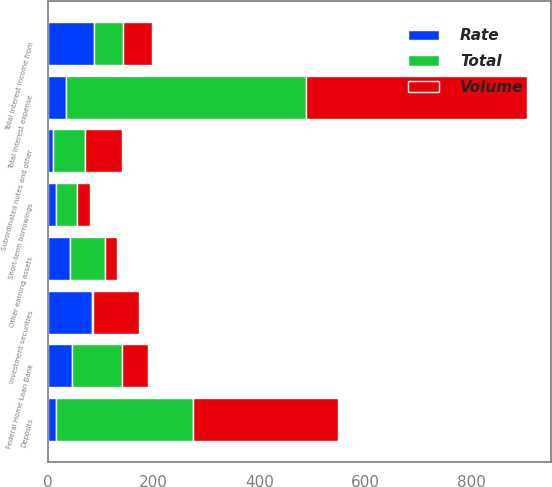Convert chart to OTSL. <chart><loc_0><loc_0><loc_500><loc_500><stacked_bar_chart><ecel><fcel>Investment securities<fcel>Other earning assets<fcel>Total interest income from<fcel>Deposits<fcel>Short-term borrowings<fcel>Federal Home Loan Bank<fcel>Subordinated notes and other<fcel>Total interest expense<nl><fcel>Rate<fcel>84.4<fcel>42.1<fcel>87.9<fcel>16.5<fcel>16.6<fcel>45.3<fcel>9.8<fcel>35.6<nl><fcel>Volume<fcel>86.3<fcel>23.4<fcel>54.95<fcel>274.1<fcel>23.3<fcel>49.6<fcel>70.1<fcel>417.1<nl><fcel>Total<fcel>1.9<fcel>65.5<fcel>54.95<fcel>257.6<fcel>39.9<fcel>94.9<fcel>60.3<fcel>452.7<nl></chart> 